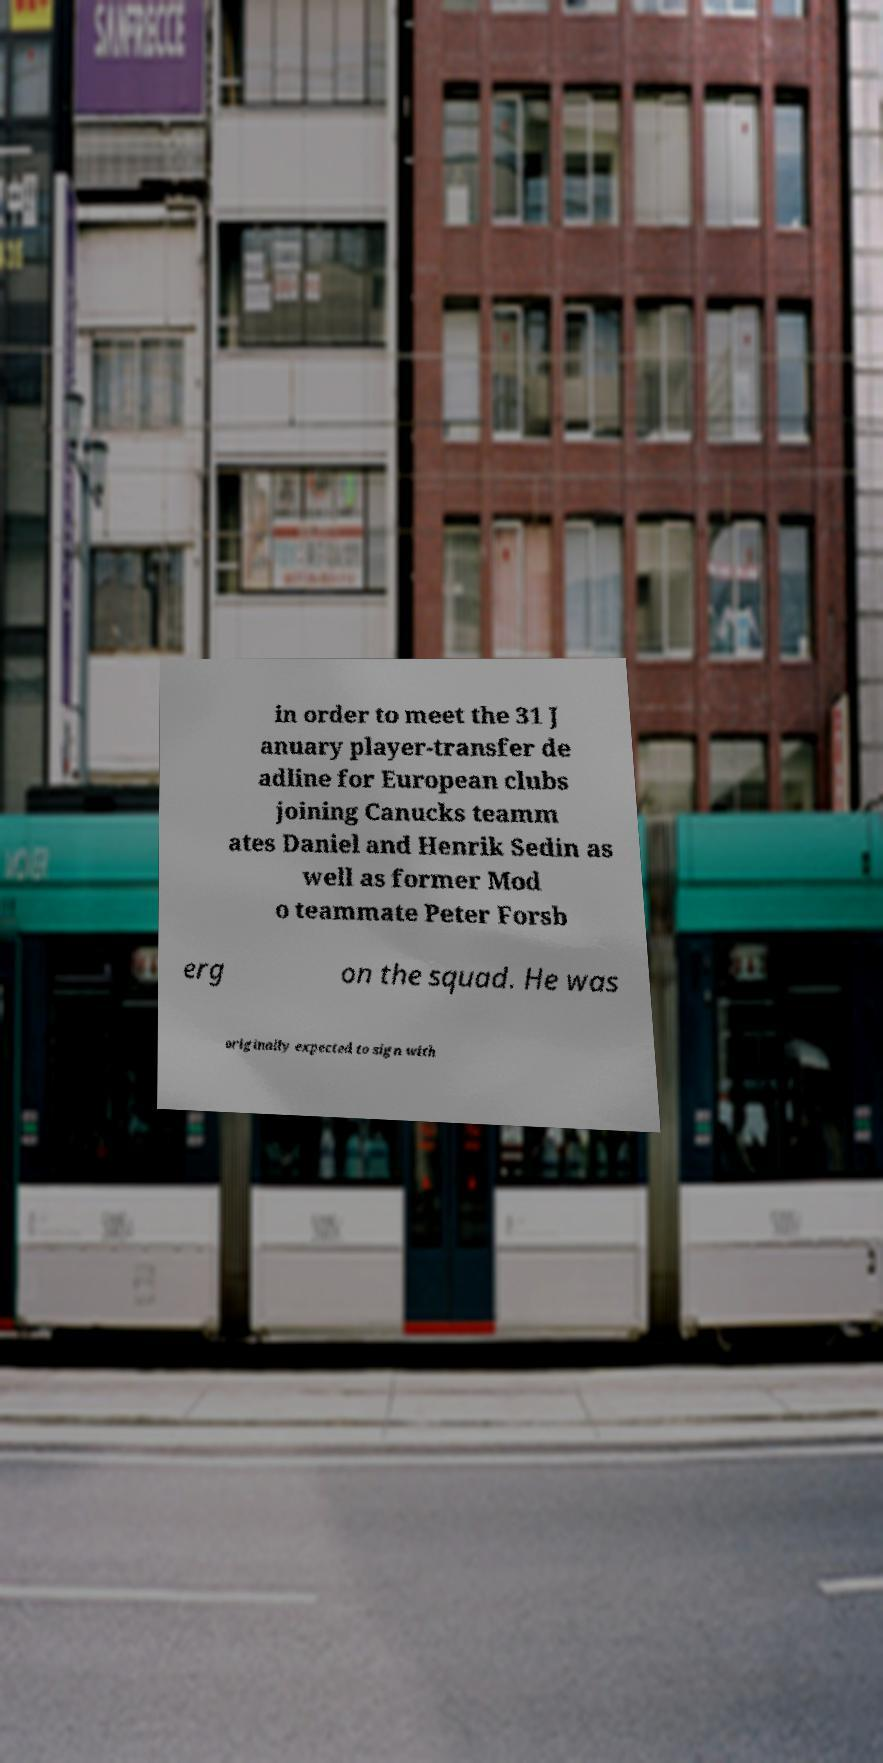Could you extract and type out the text from this image? in order to meet the 31 J anuary player-transfer de adline for European clubs joining Canucks teamm ates Daniel and Henrik Sedin as well as former Mod o teammate Peter Forsb erg on the squad. He was originally expected to sign with 